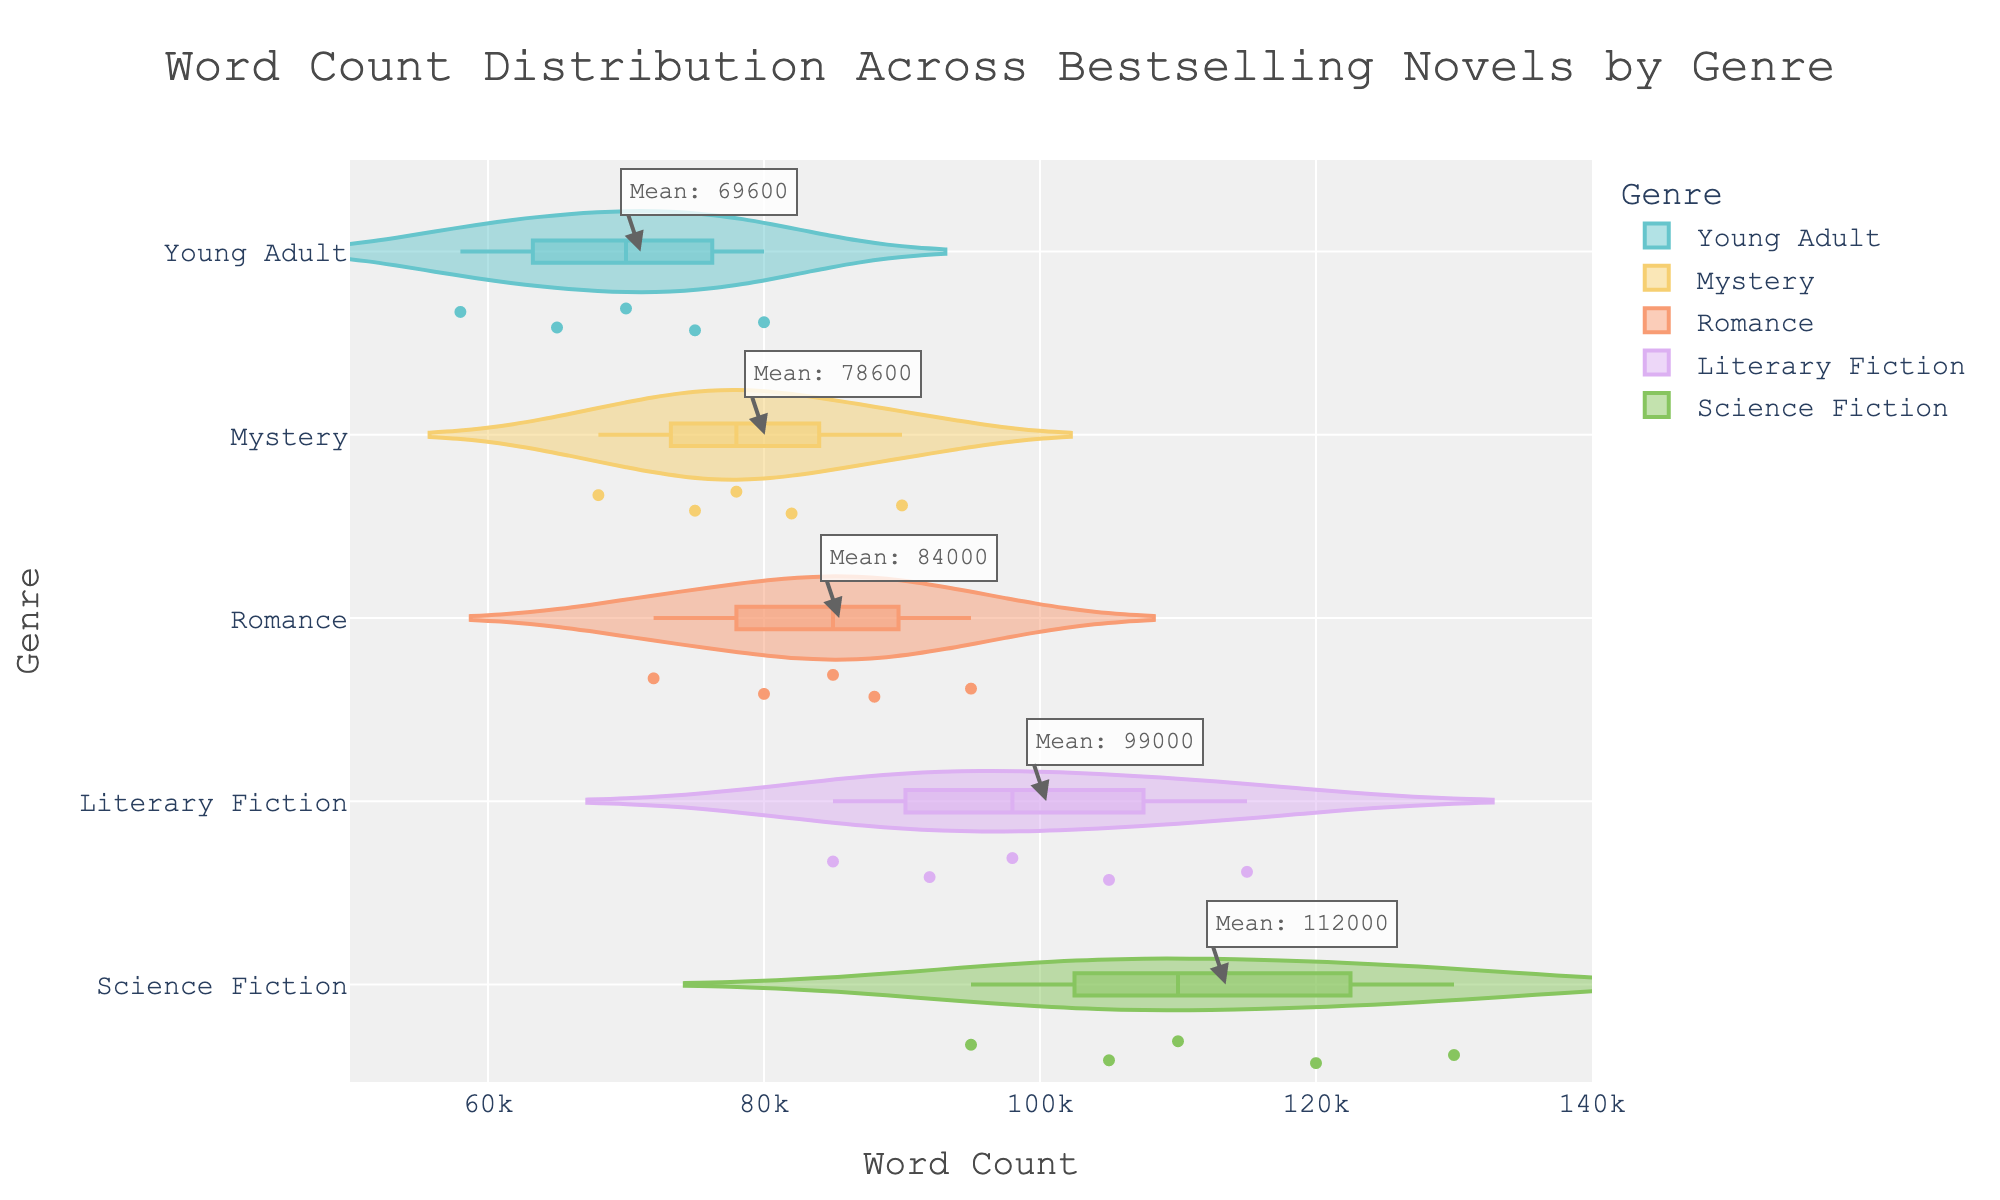What is the title of the plot? The title is usually placed at the top of the chart and tells us what the plot represents. It helps viewers quickly understand the context of the data being shown.
Answer: Word Count Distribution Across Bestselling Novels by Genre Which genre has the highest mean word count? The mean word count is annotated on the plot for each genre. By looking at these annotations, we can identify which genre has the highest value.
Answer: Science Fiction What is the average word count for Mystery novels? The mean word count for each genre is provided as a text annotation on the plot. For Mystery, we can directly read this annotation.
Answer: 78,000 How does the mean word count of Romance novels compare to that of Literary Fiction novels? We can compare the text annotations for both genres. Romance novels have a mean word count of 84,500, while Literary Fiction novels have a mean of 99,000. Since 84,500 is less than 99,000, Literary Fiction novels have a higher mean word count.
Answer: Literary Fiction novels have a higher mean word count Which genre shows the widest distribution of word counts? The width of the distribution in a violin plot indicates variability in the data. By comparing the widths of distributions for each genre, we can observe which one is the widest.
Answer: Science Fiction What is the approximate word count range for Young Adult novels? By observing the plot, we can see the vertical extent of the distribution for Young Adult novels. The data points and the outline of the violin plot indicate the range.
Answer: Approximately 58,000 to 80,000 Are there any genres with a word count below 60,000? We can look at the leftmost points in each genre's distribution to see if any distributions extend below 60,000. Only Young Adult novels have data points below this threshold.
Answer: Yes, Young Adult How does the spread of word counts in Mystery novels compare to that in Romance novels? Compare the violin plots for Mystery and Romance genres. We can see how spread out or clustered the word counts are by assessing the width and density of each distribution.
Answer: Romance novels have a wider spread than Mystery novels What is the median word count for Science Fiction novels? The median is indicated by a horizontal line within the box plot component of the violin plot. By examining this line for Science Fiction, we can determine the median.
Answer: 115,000 Which genres show the presence of outliers? In a violin plot with points shown, outliers appear as isolated points outside the main body of the distribution. By evaluating each genre, we can identify any outliers.
Answer: Science Fiction, Romance, Literary Fiction 